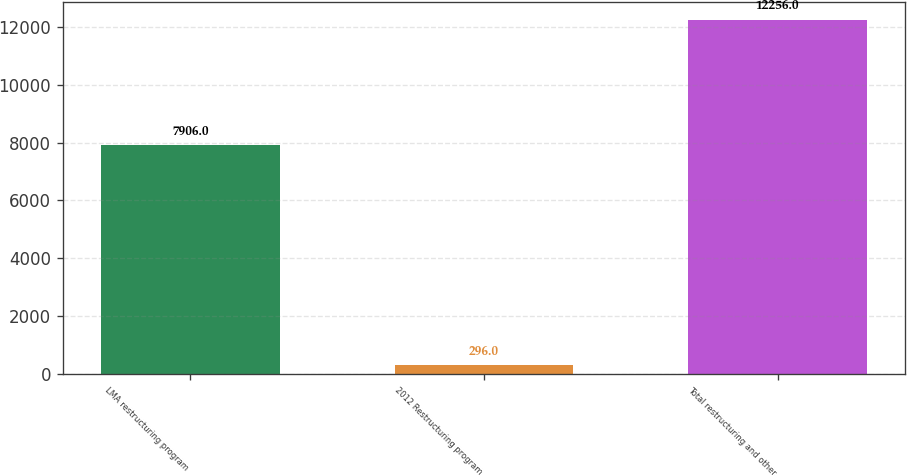Convert chart. <chart><loc_0><loc_0><loc_500><loc_500><bar_chart><fcel>LMA restructuring program<fcel>2012 Restructuring program<fcel>Total restructuring and other<nl><fcel>7906<fcel>296<fcel>12256<nl></chart> 